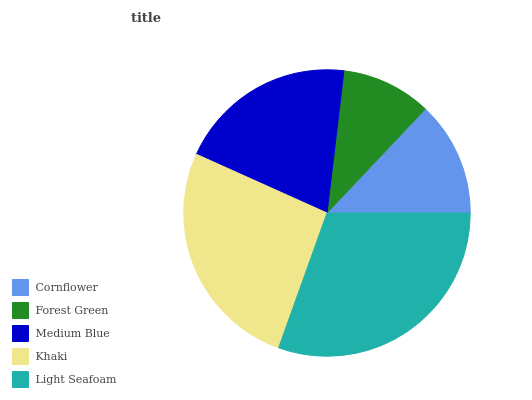Is Forest Green the minimum?
Answer yes or no. Yes. Is Light Seafoam the maximum?
Answer yes or no. Yes. Is Medium Blue the minimum?
Answer yes or no. No. Is Medium Blue the maximum?
Answer yes or no. No. Is Medium Blue greater than Forest Green?
Answer yes or no. Yes. Is Forest Green less than Medium Blue?
Answer yes or no. Yes. Is Forest Green greater than Medium Blue?
Answer yes or no. No. Is Medium Blue less than Forest Green?
Answer yes or no. No. Is Medium Blue the high median?
Answer yes or no. Yes. Is Medium Blue the low median?
Answer yes or no. Yes. Is Cornflower the high median?
Answer yes or no. No. Is Forest Green the low median?
Answer yes or no. No. 